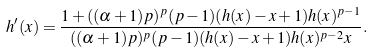<formula> <loc_0><loc_0><loc_500><loc_500>h ^ { \prime } ( x ) = \frac { 1 + ( ( \alpha + 1 ) p ) ^ { p } ( p - 1 ) ( h ( x ) - x + 1 ) h ( x ) ^ { p - 1 } } { ( ( \alpha + 1 ) p ) ^ { p } ( p - 1 ) ( h ( x ) - x + 1 ) h ( x ) ^ { p - 2 } x } .</formula> 